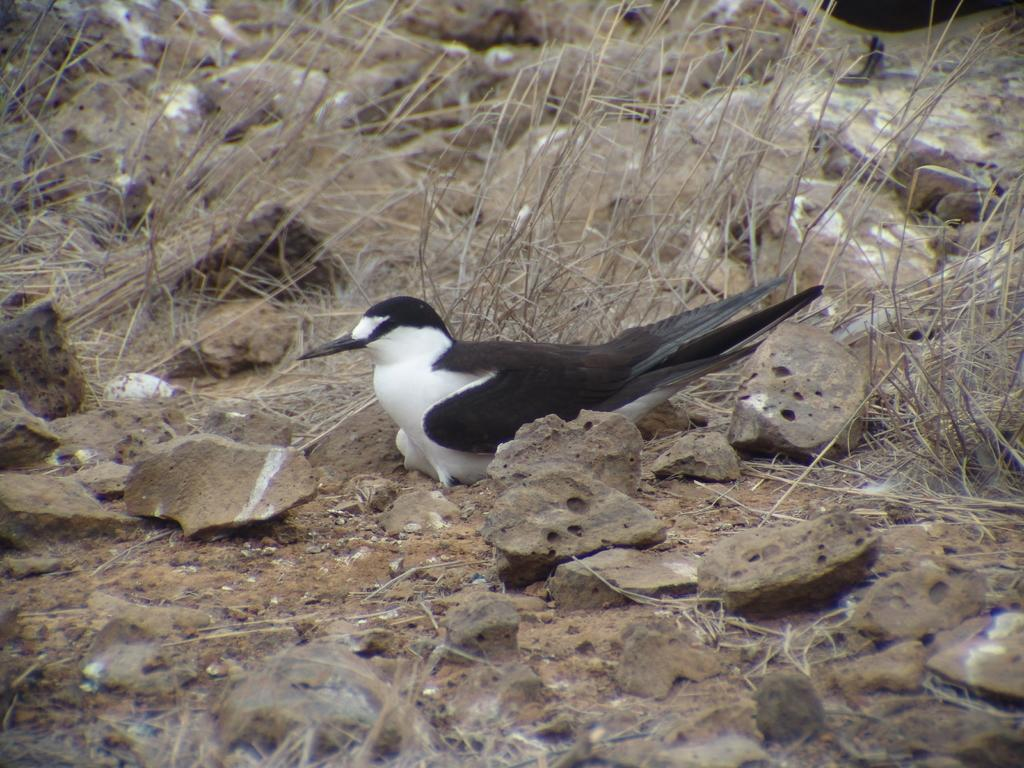What type of animal is in the image? There is a bird in the image. What colors can be seen on the bird? The bird is in white and black color. What other objects are present in the image? There are stones and dried grass in the image. What is the color of the dried grass? The grass is in brown color. What thought is the bird having while sitting on the stones? It is impossible to determine the bird's thoughts from the image, as animals do not have the ability to express their thoughts in a way that can be observed visually. 